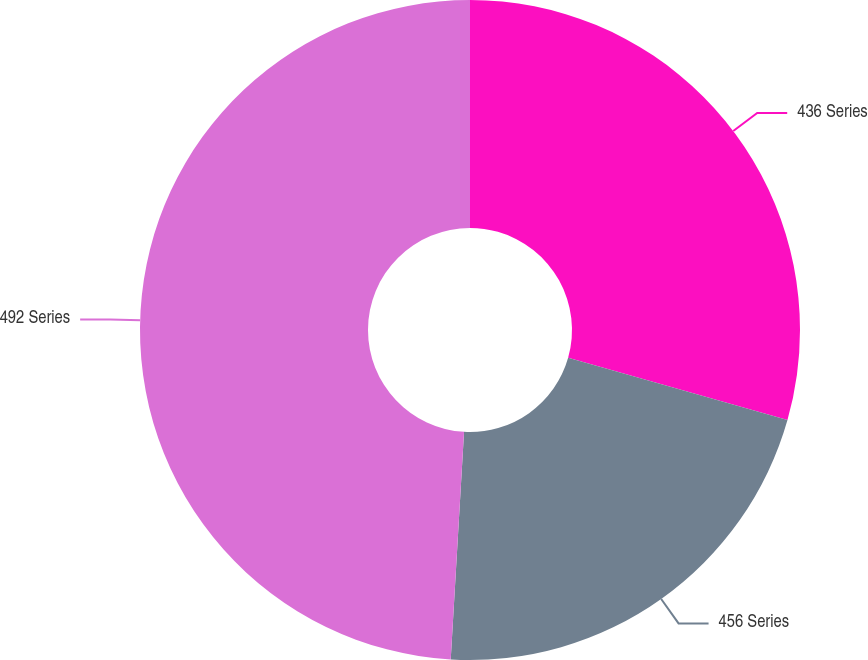Convert chart. <chart><loc_0><loc_0><loc_500><loc_500><pie_chart><fcel>436 Series<fcel>456 Series<fcel>492 Series<nl><fcel>29.4%<fcel>21.53%<fcel>49.07%<nl></chart> 